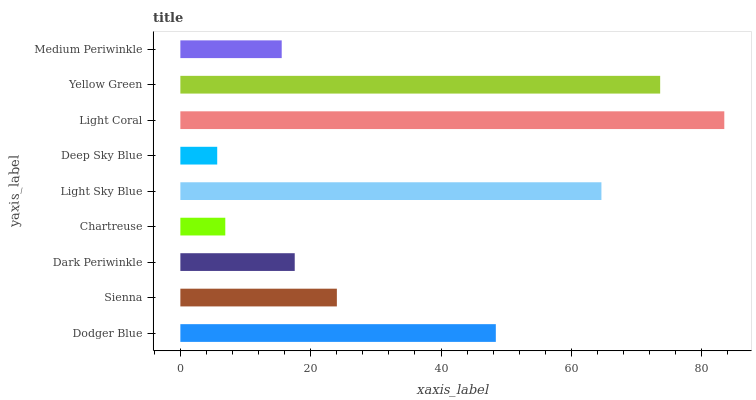Is Deep Sky Blue the minimum?
Answer yes or no. Yes. Is Light Coral the maximum?
Answer yes or no. Yes. Is Sienna the minimum?
Answer yes or no. No. Is Sienna the maximum?
Answer yes or no. No. Is Dodger Blue greater than Sienna?
Answer yes or no. Yes. Is Sienna less than Dodger Blue?
Answer yes or no. Yes. Is Sienna greater than Dodger Blue?
Answer yes or no. No. Is Dodger Blue less than Sienna?
Answer yes or no. No. Is Sienna the high median?
Answer yes or no. Yes. Is Sienna the low median?
Answer yes or no. Yes. Is Light Coral the high median?
Answer yes or no. No. Is Light Sky Blue the low median?
Answer yes or no. No. 